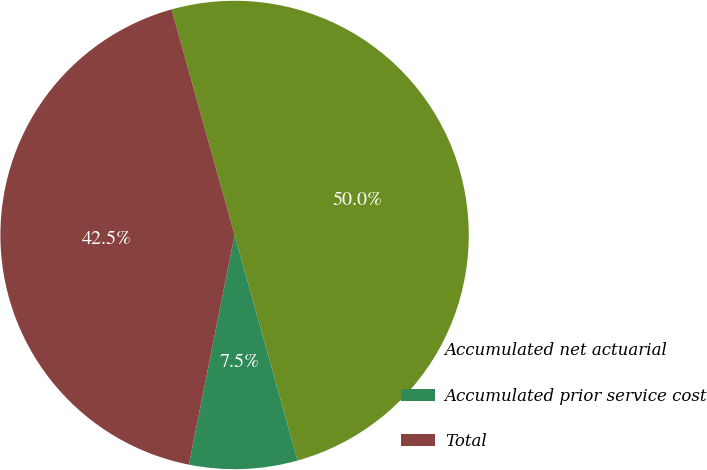Convert chart. <chart><loc_0><loc_0><loc_500><loc_500><pie_chart><fcel>Accumulated net actuarial<fcel>Accumulated prior service cost<fcel>Total<nl><fcel>50.0%<fcel>7.46%<fcel>42.54%<nl></chart> 